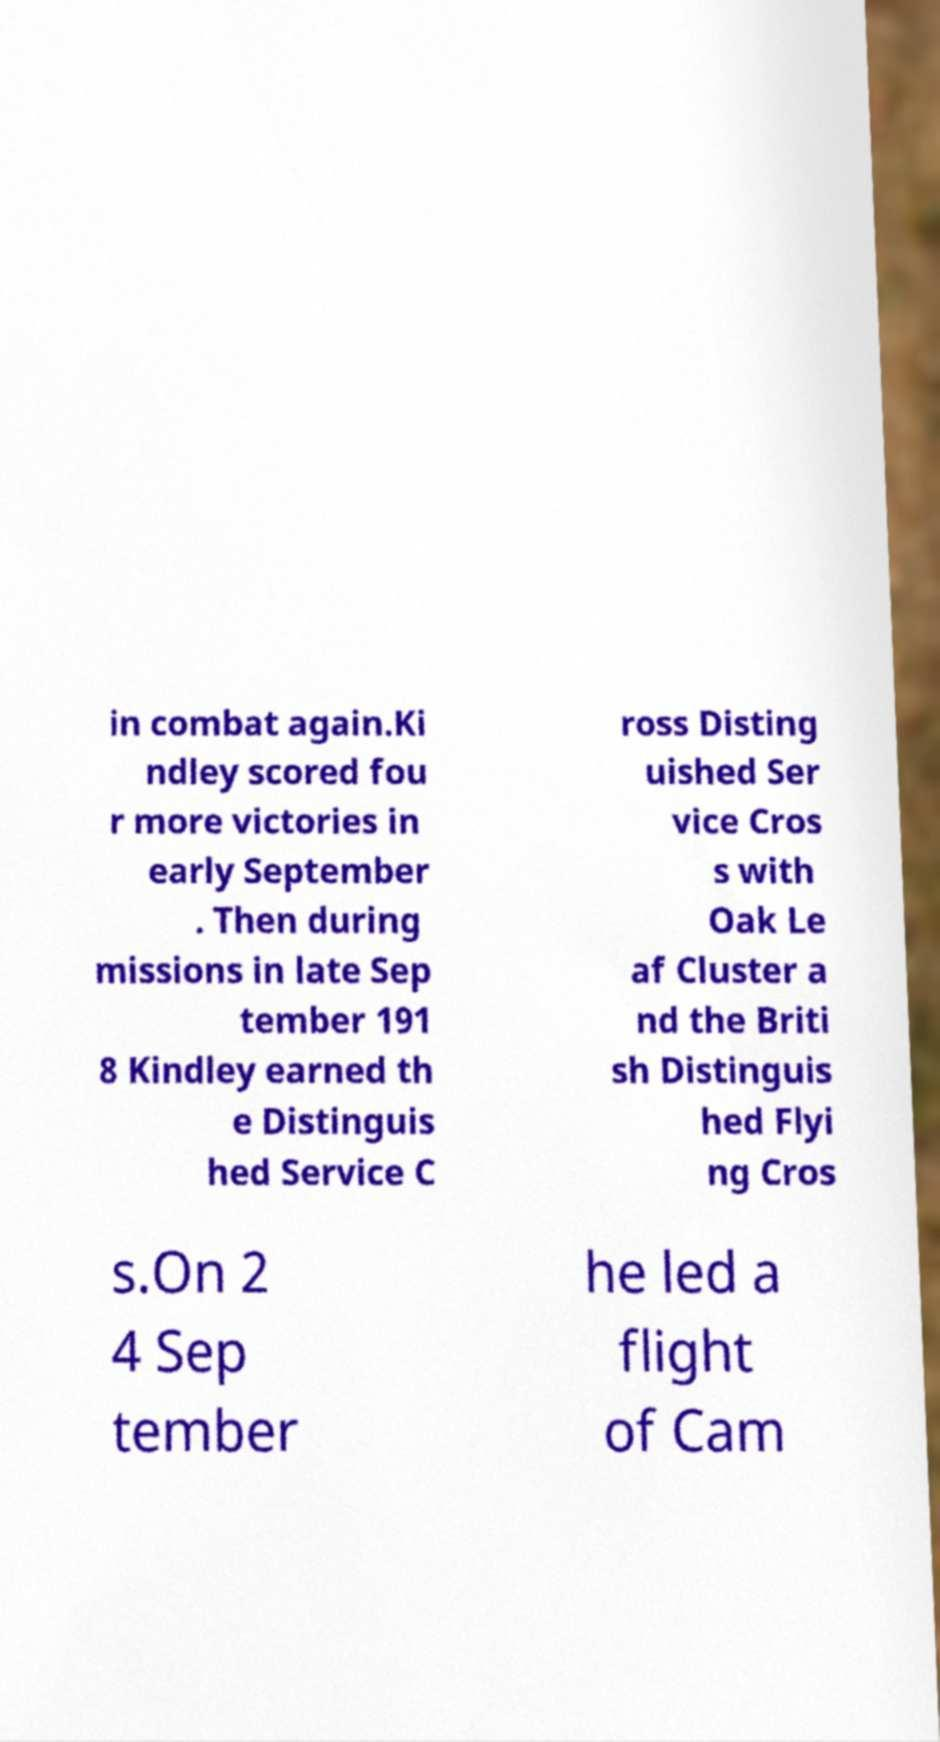There's text embedded in this image that I need extracted. Can you transcribe it verbatim? in combat again.Ki ndley scored fou r more victories in early September . Then during missions in late Sep tember 191 8 Kindley earned th e Distinguis hed Service C ross Disting uished Ser vice Cros s with Oak Le af Cluster a nd the Briti sh Distinguis hed Flyi ng Cros s.On 2 4 Sep tember he led a flight of Cam 